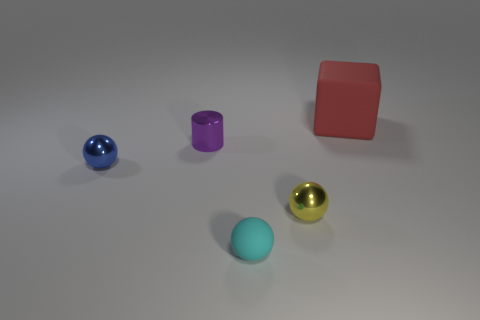Subtract 3 balls. How many balls are left? 0 Subtract all small metal spheres. How many spheres are left? 1 Add 3 objects. How many objects exist? 8 Add 2 small objects. How many objects exist? 7 Subtract all blue balls. How many balls are left? 2 Subtract 0 gray balls. How many objects are left? 5 Subtract all cylinders. How many objects are left? 4 Subtract all green cylinders. Subtract all brown balls. How many cylinders are left? 1 Subtract all cyan blocks. How many yellow balls are left? 1 Subtract all big blue rubber balls. Subtract all cubes. How many objects are left? 4 